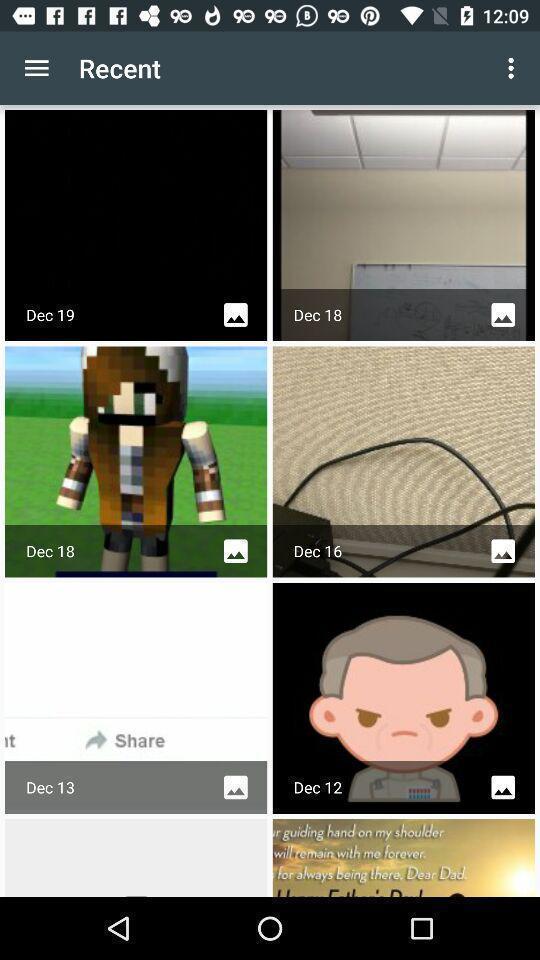What can you discern from this picture? Screen showing list of various recent images. 